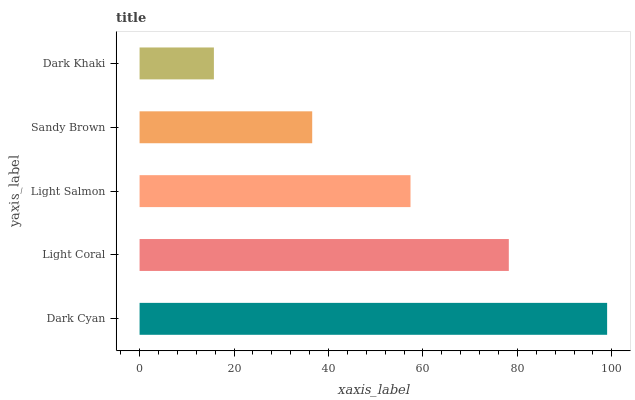Is Dark Khaki the minimum?
Answer yes or no. Yes. Is Dark Cyan the maximum?
Answer yes or no. Yes. Is Light Coral the minimum?
Answer yes or no. No. Is Light Coral the maximum?
Answer yes or no. No. Is Dark Cyan greater than Light Coral?
Answer yes or no. Yes. Is Light Coral less than Dark Cyan?
Answer yes or no. Yes. Is Light Coral greater than Dark Cyan?
Answer yes or no. No. Is Dark Cyan less than Light Coral?
Answer yes or no. No. Is Light Salmon the high median?
Answer yes or no. Yes. Is Light Salmon the low median?
Answer yes or no. Yes. Is Sandy Brown the high median?
Answer yes or no. No. Is Light Coral the low median?
Answer yes or no. No. 